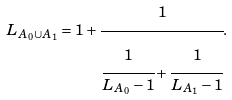Convert formula to latex. <formula><loc_0><loc_0><loc_500><loc_500>L _ { A _ { 0 } \cup A _ { 1 } } = 1 + \cfrac { 1 } { \cfrac { 1 } { L _ { A _ { 0 } } - 1 } + \cfrac { 1 } { L _ { A _ { 1 } } - 1 } } .</formula> 